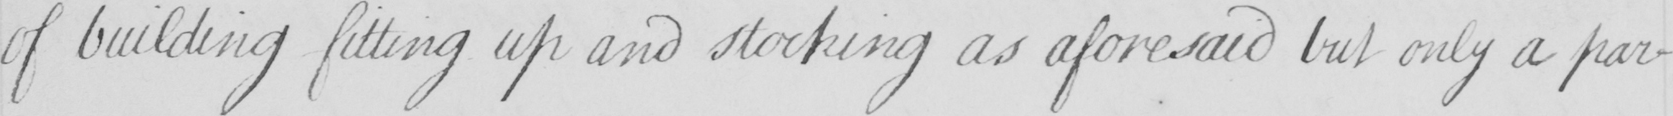Please provide the text content of this handwritten line. of building fitting up and stocking as aforesaid but only a par- 